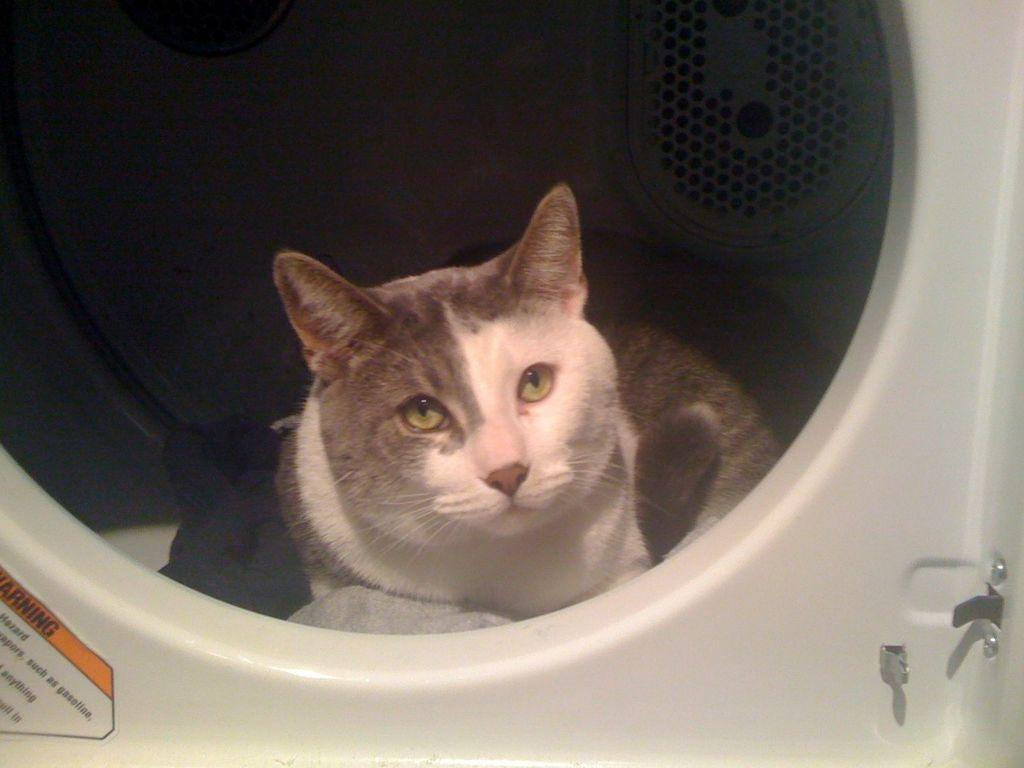What animal is in the foreground of the image? There is a cat in the foreground of the image. Where is the cat located in the image? The cat appears to be in a washing machine. What type of land can be seen in the background of the image? There is no land visible in the image, as the cat is in a washing machine. 